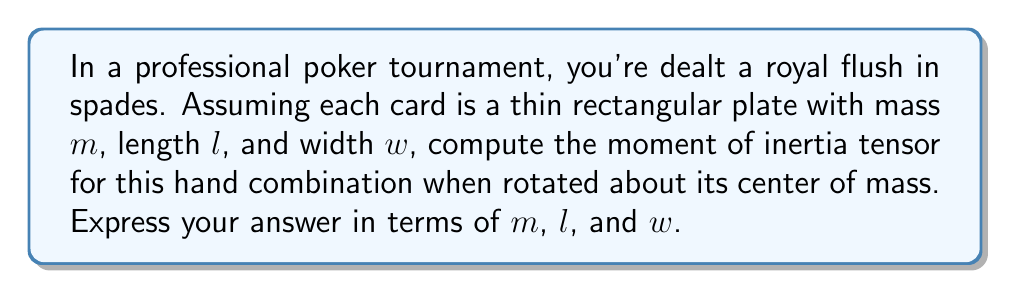Provide a solution to this math problem. Let's approach this step-by-step:

1) A royal flush consists of five cards: 10, Jack, Queen, King, and Ace of the same suit. We'll treat each card as a thin rectangular plate.

2) The moment of inertia tensor for a thin rectangular plate about its center of mass is:

   $$I = \begin{bmatrix}
   I_{xx} & 0 & 0 \\
   0 & I_{yy} & 0 \\
   0 & 0 & I_{zz}
   \end{bmatrix}$$

   Where:
   $$I_{xx} = \frac{1}{12}m(w^2 + l^2)$$
   $$I_{yy} = \frac{1}{12}m(l^2 + w^2)$$
   $$I_{zz} = \frac{1}{12}m(l^2 + w^2)$$

3) For the entire hand, we need to sum the contributions of all five cards. Since they are identical, we can multiply the tensor of a single card by 5:

   $$I_{total} = 5 \cdot \begin{bmatrix}
   \frac{1}{12}m(w^2 + l^2) & 0 & 0 \\
   0 & \frac{1}{12}m(l^2 + w^2) & 0 \\
   0 & 0 & \frac{1}{12}m(l^2 + w^2)
   \end{bmatrix}$$

4) Simplifying:

   $$I_{total} = \frac{5m}{12} \begin{bmatrix}
   w^2 + l^2 & 0 & 0 \\
   0 & l^2 + w^2 & 0 \\
   0 & 0 & l^2 + w^2
   \end{bmatrix}$$

This is the moment of inertia tensor for the royal flush hand combination.
Answer: $$\frac{5m}{12} \begin{bmatrix}
w^2 + l^2 & 0 & 0 \\
0 & l^2 + w^2 & 0 \\
0 & 0 & l^2 + w^2
\end{bmatrix}$$ 